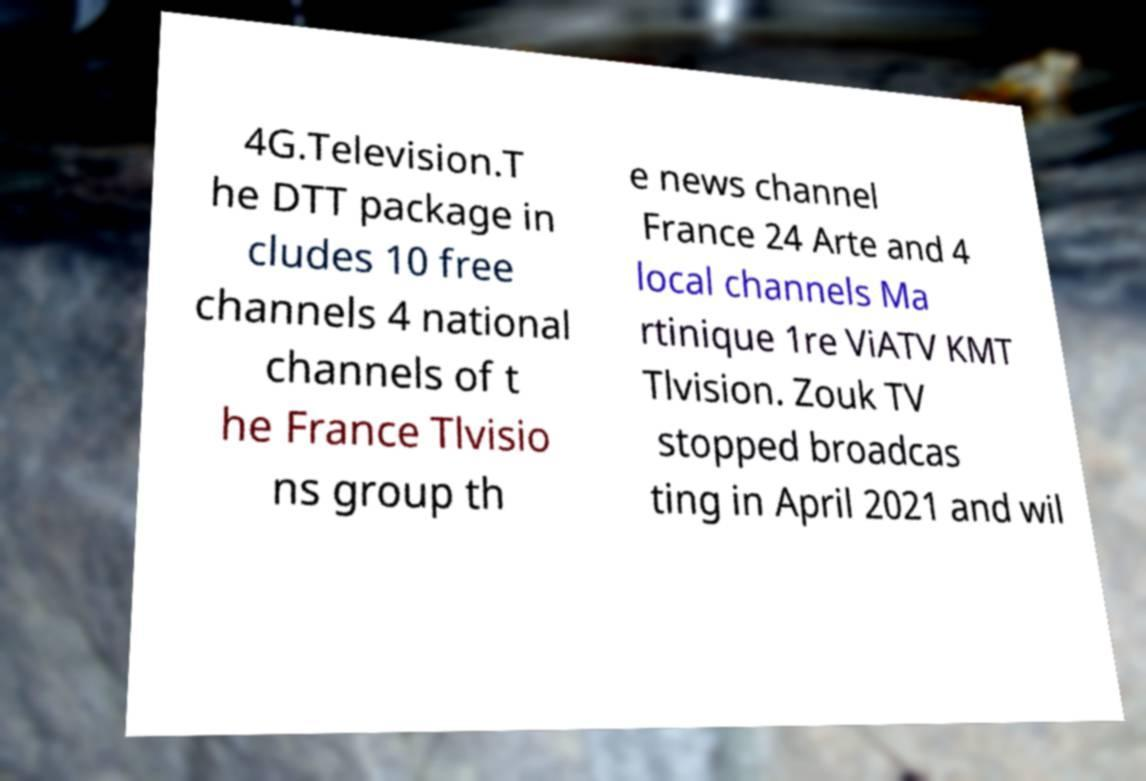Could you extract and type out the text from this image? 4G.Television.T he DTT package in cludes 10 free channels 4 national channels of t he France Tlvisio ns group th e news channel France 24 Arte and 4 local channels Ma rtinique 1re ViATV KMT Tlvision. Zouk TV stopped broadcas ting in April 2021 and wil 